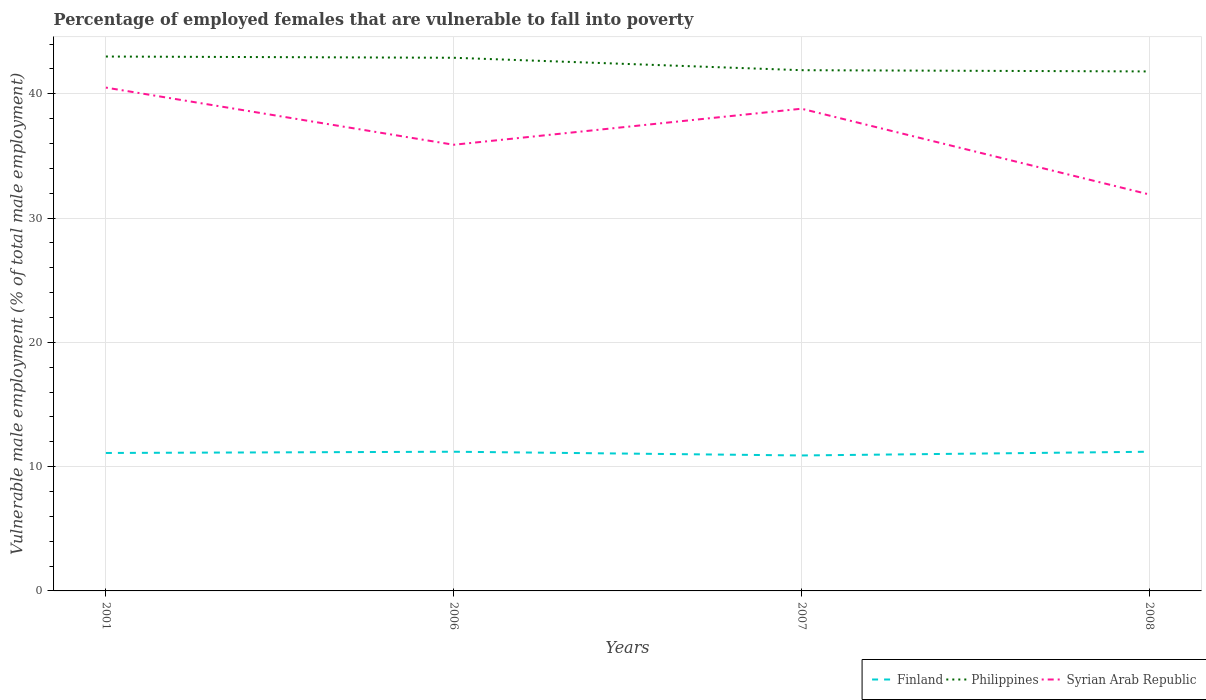Does the line corresponding to Finland intersect with the line corresponding to Syrian Arab Republic?
Offer a terse response. No. Across all years, what is the maximum percentage of employed females who are vulnerable to fall into poverty in Philippines?
Your response must be concise. 41.8. What is the total percentage of employed females who are vulnerable to fall into poverty in Finland in the graph?
Your answer should be very brief. -0.1. What is the difference between the highest and the second highest percentage of employed females who are vulnerable to fall into poverty in Finland?
Your response must be concise. 0.3. What is the difference between the highest and the lowest percentage of employed females who are vulnerable to fall into poverty in Finland?
Offer a very short reply. 3. Is the percentage of employed females who are vulnerable to fall into poverty in Syrian Arab Republic strictly greater than the percentage of employed females who are vulnerable to fall into poverty in Finland over the years?
Make the answer very short. No. What is the difference between two consecutive major ticks on the Y-axis?
Ensure brevity in your answer.  10. Are the values on the major ticks of Y-axis written in scientific E-notation?
Your response must be concise. No. Does the graph contain grids?
Your answer should be very brief. Yes. How are the legend labels stacked?
Give a very brief answer. Horizontal. What is the title of the graph?
Keep it short and to the point. Percentage of employed females that are vulnerable to fall into poverty. Does "Comoros" appear as one of the legend labels in the graph?
Your answer should be very brief. No. What is the label or title of the Y-axis?
Provide a short and direct response. Vulnerable male employment (% of total male employment). What is the Vulnerable male employment (% of total male employment) in Finland in 2001?
Your answer should be very brief. 11.1. What is the Vulnerable male employment (% of total male employment) in Syrian Arab Republic in 2001?
Provide a short and direct response. 40.5. What is the Vulnerable male employment (% of total male employment) of Finland in 2006?
Ensure brevity in your answer.  11.2. What is the Vulnerable male employment (% of total male employment) of Philippines in 2006?
Your response must be concise. 42.9. What is the Vulnerable male employment (% of total male employment) in Syrian Arab Republic in 2006?
Provide a succinct answer. 35.9. What is the Vulnerable male employment (% of total male employment) in Finland in 2007?
Give a very brief answer. 10.9. What is the Vulnerable male employment (% of total male employment) in Philippines in 2007?
Offer a very short reply. 41.9. What is the Vulnerable male employment (% of total male employment) of Syrian Arab Republic in 2007?
Your answer should be very brief. 38.8. What is the Vulnerable male employment (% of total male employment) of Finland in 2008?
Provide a short and direct response. 11.2. What is the Vulnerable male employment (% of total male employment) of Philippines in 2008?
Keep it short and to the point. 41.8. What is the Vulnerable male employment (% of total male employment) of Syrian Arab Republic in 2008?
Your answer should be very brief. 31.9. Across all years, what is the maximum Vulnerable male employment (% of total male employment) in Finland?
Offer a terse response. 11.2. Across all years, what is the maximum Vulnerable male employment (% of total male employment) in Syrian Arab Republic?
Make the answer very short. 40.5. Across all years, what is the minimum Vulnerable male employment (% of total male employment) in Finland?
Keep it short and to the point. 10.9. Across all years, what is the minimum Vulnerable male employment (% of total male employment) of Philippines?
Make the answer very short. 41.8. Across all years, what is the minimum Vulnerable male employment (% of total male employment) of Syrian Arab Republic?
Your answer should be very brief. 31.9. What is the total Vulnerable male employment (% of total male employment) in Finland in the graph?
Make the answer very short. 44.4. What is the total Vulnerable male employment (% of total male employment) in Philippines in the graph?
Ensure brevity in your answer.  169.6. What is the total Vulnerable male employment (% of total male employment) of Syrian Arab Republic in the graph?
Make the answer very short. 147.1. What is the difference between the Vulnerable male employment (% of total male employment) in Philippines in 2001 and that in 2006?
Your answer should be very brief. 0.1. What is the difference between the Vulnerable male employment (% of total male employment) in Finland in 2001 and that in 2007?
Provide a short and direct response. 0.2. What is the difference between the Vulnerable male employment (% of total male employment) of Philippines in 2001 and that in 2007?
Your answer should be very brief. 1.1. What is the difference between the Vulnerable male employment (% of total male employment) in Syrian Arab Republic in 2001 and that in 2007?
Offer a very short reply. 1.7. What is the difference between the Vulnerable male employment (% of total male employment) in Finland in 2001 and that in 2008?
Offer a very short reply. -0.1. What is the difference between the Vulnerable male employment (% of total male employment) of Philippines in 2001 and that in 2008?
Give a very brief answer. 1.2. What is the difference between the Vulnerable male employment (% of total male employment) of Syrian Arab Republic in 2001 and that in 2008?
Give a very brief answer. 8.6. What is the difference between the Vulnerable male employment (% of total male employment) in Finland in 2006 and that in 2007?
Your answer should be very brief. 0.3. What is the difference between the Vulnerable male employment (% of total male employment) in Philippines in 2006 and that in 2007?
Ensure brevity in your answer.  1. What is the difference between the Vulnerable male employment (% of total male employment) in Philippines in 2006 and that in 2008?
Provide a succinct answer. 1.1. What is the difference between the Vulnerable male employment (% of total male employment) of Syrian Arab Republic in 2006 and that in 2008?
Your answer should be very brief. 4. What is the difference between the Vulnerable male employment (% of total male employment) in Philippines in 2007 and that in 2008?
Provide a succinct answer. 0.1. What is the difference between the Vulnerable male employment (% of total male employment) in Syrian Arab Republic in 2007 and that in 2008?
Your response must be concise. 6.9. What is the difference between the Vulnerable male employment (% of total male employment) of Finland in 2001 and the Vulnerable male employment (% of total male employment) of Philippines in 2006?
Provide a succinct answer. -31.8. What is the difference between the Vulnerable male employment (% of total male employment) of Finland in 2001 and the Vulnerable male employment (% of total male employment) of Syrian Arab Republic in 2006?
Provide a short and direct response. -24.8. What is the difference between the Vulnerable male employment (% of total male employment) in Finland in 2001 and the Vulnerable male employment (% of total male employment) in Philippines in 2007?
Offer a terse response. -30.8. What is the difference between the Vulnerable male employment (% of total male employment) of Finland in 2001 and the Vulnerable male employment (% of total male employment) of Syrian Arab Republic in 2007?
Keep it short and to the point. -27.7. What is the difference between the Vulnerable male employment (% of total male employment) of Philippines in 2001 and the Vulnerable male employment (% of total male employment) of Syrian Arab Republic in 2007?
Your answer should be compact. 4.2. What is the difference between the Vulnerable male employment (% of total male employment) in Finland in 2001 and the Vulnerable male employment (% of total male employment) in Philippines in 2008?
Your answer should be compact. -30.7. What is the difference between the Vulnerable male employment (% of total male employment) of Finland in 2001 and the Vulnerable male employment (% of total male employment) of Syrian Arab Republic in 2008?
Provide a succinct answer. -20.8. What is the difference between the Vulnerable male employment (% of total male employment) in Finland in 2006 and the Vulnerable male employment (% of total male employment) in Philippines in 2007?
Offer a terse response. -30.7. What is the difference between the Vulnerable male employment (% of total male employment) in Finland in 2006 and the Vulnerable male employment (% of total male employment) in Syrian Arab Republic in 2007?
Make the answer very short. -27.6. What is the difference between the Vulnerable male employment (% of total male employment) of Philippines in 2006 and the Vulnerable male employment (% of total male employment) of Syrian Arab Republic in 2007?
Your answer should be very brief. 4.1. What is the difference between the Vulnerable male employment (% of total male employment) in Finland in 2006 and the Vulnerable male employment (% of total male employment) in Philippines in 2008?
Provide a short and direct response. -30.6. What is the difference between the Vulnerable male employment (% of total male employment) of Finland in 2006 and the Vulnerable male employment (% of total male employment) of Syrian Arab Republic in 2008?
Your answer should be compact. -20.7. What is the difference between the Vulnerable male employment (% of total male employment) of Finland in 2007 and the Vulnerable male employment (% of total male employment) of Philippines in 2008?
Ensure brevity in your answer.  -30.9. What is the average Vulnerable male employment (% of total male employment) of Finland per year?
Give a very brief answer. 11.1. What is the average Vulnerable male employment (% of total male employment) of Philippines per year?
Your response must be concise. 42.4. What is the average Vulnerable male employment (% of total male employment) of Syrian Arab Republic per year?
Your answer should be very brief. 36.77. In the year 2001, what is the difference between the Vulnerable male employment (% of total male employment) in Finland and Vulnerable male employment (% of total male employment) in Philippines?
Provide a succinct answer. -31.9. In the year 2001, what is the difference between the Vulnerable male employment (% of total male employment) in Finland and Vulnerable male employment (% of total male employment) in Syrian Arab Republic?
Your response must be concise. -29.4. In the year 2006, what is the difference between the Vulnerable male employment (% of total male employment) of Finland and Vulnerable male employment (% of total male employment) of Philippines?
Keep it short and to the point. -31.7. In the year 2006, what is the difference between the Vulnerable male employment (% of total male employment) in Finland and Vulnerable male employment (% of total male employment) in Syrian Arab Republic?
Your answer should be very brief. -24.7. In the year 2007, what is the difference between the Vulnerable male employment (% of total male employment) of Finland and Vulnerable male employment (% of total male employment) of Philippines?
Provide a short and direct response. -31. In the year 2007, what is the difference between the Vulnerable male employment (% of total male employment) in Finland and Vulnerable male employment (% of total male employment) in Syrian Arab Republic?
Your response must be concise. -27.9. In the year 2008, what is the difference between the Vulnerable male employment (% of total male employment) in Finland and Vulnerable male employment (% of total male employment) in Philippines?
Ensure brevity in your answer.  -30.6. In the year 2008, what is the difference between the Vulnerable male employment (% of total male employment) of Finland and Vulnerable male employment (% of total male employment) of Syrian Arab Republic?
Make the answer very short. -20.7. What is the ratio of the Vulnerable male employment (% of total male employment) of Syrian Arab Republic in 2001 to that in 2006?
Provide a succinct answer. 1.13. What is the ratio of the Vulnerable male employment (% of total male employment) in Finland in 2001 to that in 2007?
Offer a terse response. 1.02. What is the ratio of the Vulnerable male employment (% of total male employment) in Philippines in 2001 to that in 2007?
Your response must be concise. 1.03. What is the ratio of the Vulnerable male employment (% of total male employment) in Syrian Arab Republic in 2001 to that in 2007?
Provide a succinct answer. 1.04. What is the ratio of the Vulnerable male employment (% of total male employment) in Finland in 2001 to that in 2008?
Provide a short and direct response. 0.99. What is the ratio of the Vulnerable male employment (% of total male employment) of Philippines in 2001 to that in 2008?
Offer a terse response. 1.03. What is the ratio of the Vulnerable male employment (% of total male employment) in Syrian Arab Republic in 2001 to that in 2008?
Your answer should be very brief. 1.27. What is the ratio of the Vulnerable male employment (% of total male employment) in Finland in 2006 to that in 2007?
Give a very brief answer. 1.03. What is the ratio of the Vulnerable male employment (% of total male employment) of Philippines in 2006 to that in 2007?
Keep it short and to the point. 1.02. What is the ratio of the Vulnerable male employment (% of total male employment) in Syrian Arab Republic in 2006 to that in 2007?
Keep it short and to the point. 0.93. What is the ratio of the Vulnerable male employment (% of total male employment) in Finland in 2006 to that in 2008?
Provide a succinct answer. 1. What is the ratio of the Vulnerable male employment (% of total male employment) of Philippines in 2006 to that in 2008?
Give a very brief answer. 1.03. What is the ratio of the Vulnerable male employment (% of total male employment) in Syrian Arab Republic in 2006 to that in 2008?
Offer a very short reply. 1.13. What is the ratio of the Vulnerable male employment (% of total male employment) of Finland in 2007 to that in 2008?
Your answer should be very brief. 0.97. What is the ratio of the Vulnerable male employment (% of total male employment) of Philippines in 2007 to that in 2008?
Your answer should be compact. 1. What is the ratio of the Vulnerable male employment (% of total male employment) in Syrian Arab Republic in 2007 to that in 2008?
Provide a short and direct response. 1.22. What is the difference between the highest and the second highest Vulnerable male employment (% of total male employment) of Finland?
Offer a very short reply. 0. What is the difference between the highest and the second highest Vulnerable male employment (% of total male employment) in Syrian Arab Republic?
Offer a terse response. 1.7. What is the difference between the highest and the lowest Vulnerable male employment (% of total male employment) in Philippines?
Provide a short and direct response. 1.2. 